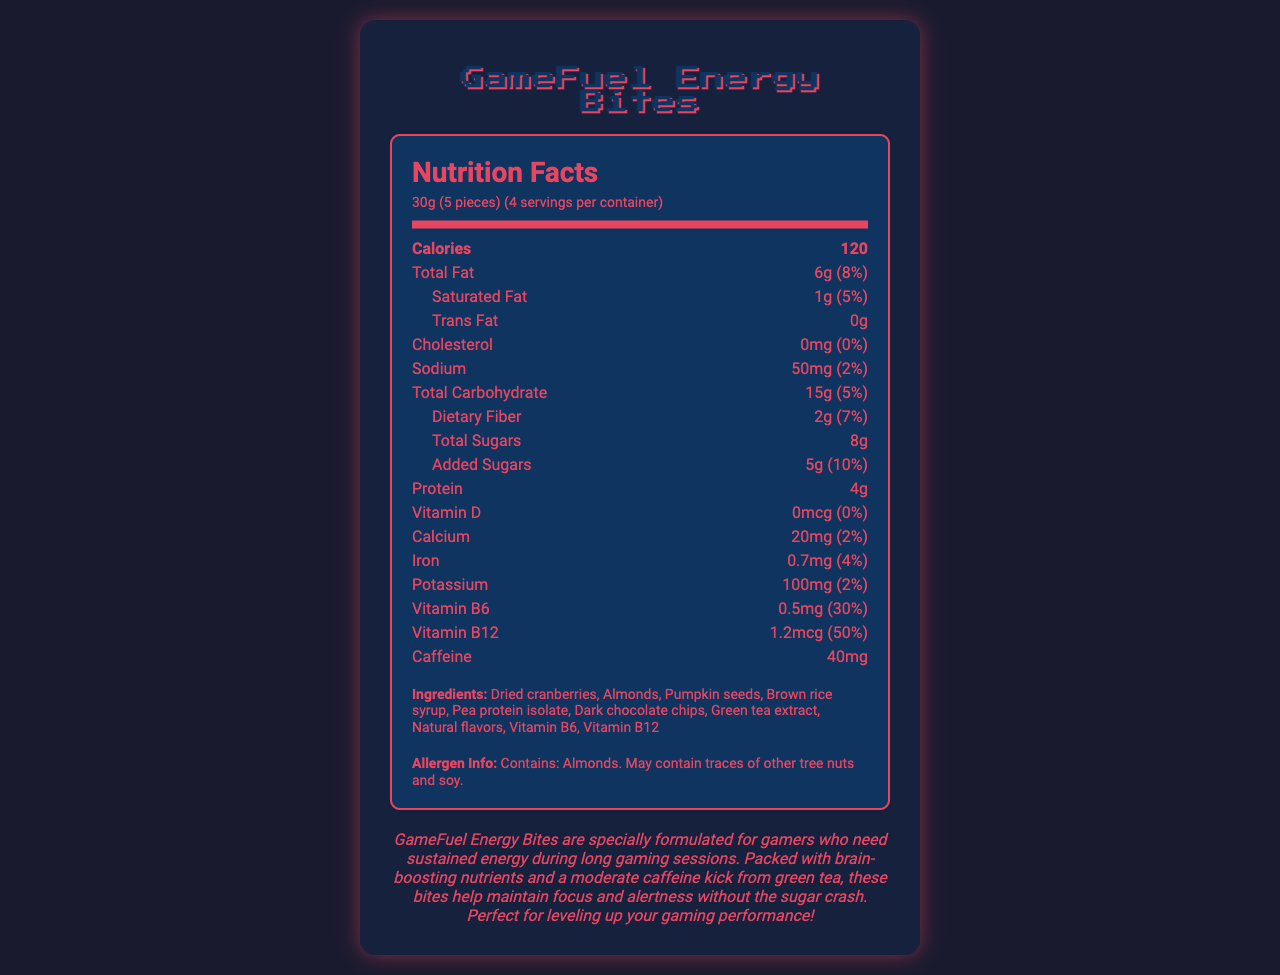what is the serving size for GameFuel Energy Bites? The serving size information is clearly listed as 30g which equals 5 pieces.
Answer: 30g (5 pieces) how many servings are in one container of GameFuel Energy Bites? The document states there are 4 servings per container.
Answer: 4 servings how many calories are in one serving of GameFuel Energy Bites? The calorie count for one serving is listed as 120 calories.
Answer: 120 calories what is the total fat content in one serving? The total fat content per serving is specified as 6g.
Answer: 6g what is the protein content in GameFuel Energy Bites? The document states that the protein content per serving is 4g.
Answer: 4g how much caffeine is in one serving of GameFuel Energy Bites? The caffeine content in one serving is listed as 40mg.
Answer: 40mg what is the daily value percentage for added sugars? A. 5% B. 7% C. 10% D. 2% The daily value percentage for added sugars is listed as 10%.
Answer: C. 10% which ingredient is not listed in GameFuel Energy Bites? A. Almonds B. Cashews C. Dark chocolate chips D. Pumpkin seeds Cashews are not listed among the ingredients.
Answer: B. Cashews are GameFuel Energy Bites suitable for people allergic to almonds? The allergen info states that it contains almonds and may contain traces of other tree nuts and soy, making it unsuitable for those allergic to almonds.
Answer: No how much vitamin B6 is provided per serving? The document indicates that each serving provides 0.5mg of Vitamin B6.
Answer: 0.5mg does GameFuel Energy Bites contain any vitamin D? The document states that the amount of vitamin D is 0mcg, which is 0% of the daily value.
Answer: No summarize the main purpose of GameFuel Energy Bites The marketing description explains that the product is designed for gamers needing prolonged energy and focus during gaming sessions, with specific nutrients and caffeine included in the formulation.
Answer: GameFuel Energy Bites are formulated to provide sustained energy for gamers, with ingredients that boost brain function and moderate caffeine to enhance focus, without causing a sugar crash. what vitamins are included in GameFuel Energy Bites? The ingredients list and nutritional facts indicate the presence of Vitamin B6 and Vitamin B12.
Answer: Vitamin B6 and Vitamin B12 who is the target audience for GameFuel Energy Bites? The marketing description clearly targets gamers by mentioning sustained energy for long gaming sessions and improved focus and alertness.
Answer: Gamers how much sodium is in one serving? The sodium content per serving is listed as 50mg.
Answer: 50mg what is the main source of caffeine in GameFuel Energy Bites? The ingredients list indicates green tea extract as a source of caffeine.
Answer: Green tea extract how much iron is provided per serving of GameFuel Energy Bites? The nutritional information states that each serving contains 0.7mg of iron.
Answer: 0.7mg are GameFuel Energy Bites free from trans fat? The trans fat content is listed as 0g.
Answer: Yes who manufactures GameFuel Energy Bites? The document does not provide information about the manufacturer.
Answer: Cannot be determined what is the total carbohydrate content per serving? The document shows that the total carbohydrate content per serving is 15g.
Answer: 15g 